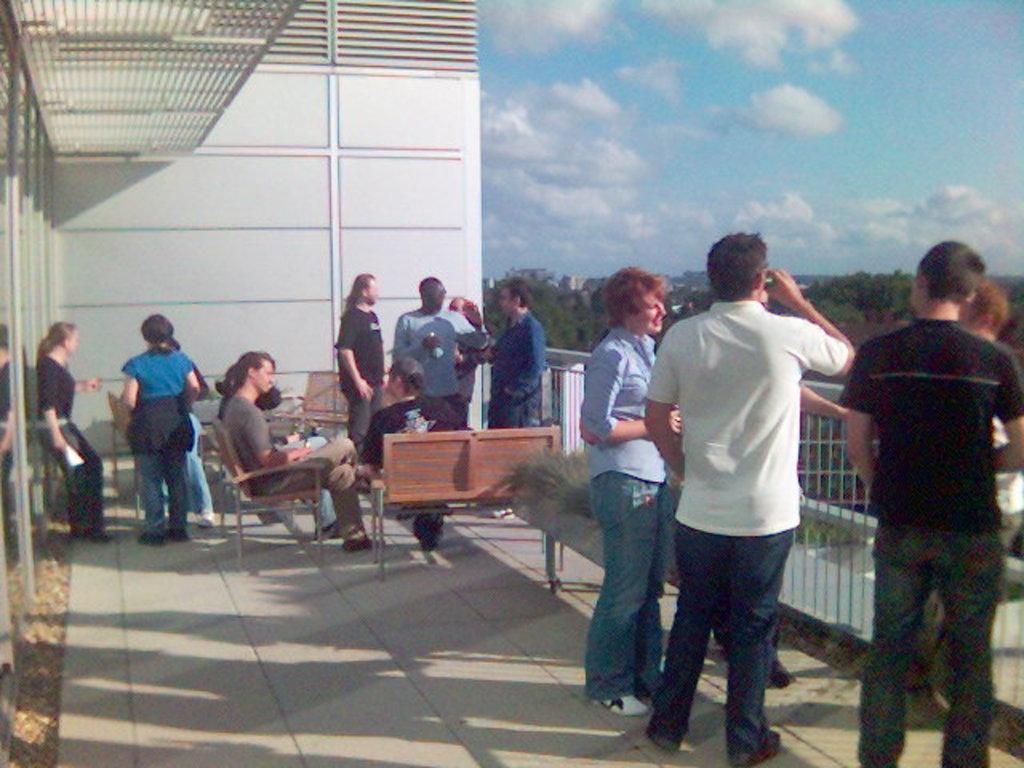Can you describe this image briefly? In this image I can see few people are standing, few are sitting on the benches. On the right side there are trees, at the top it is the sky. 